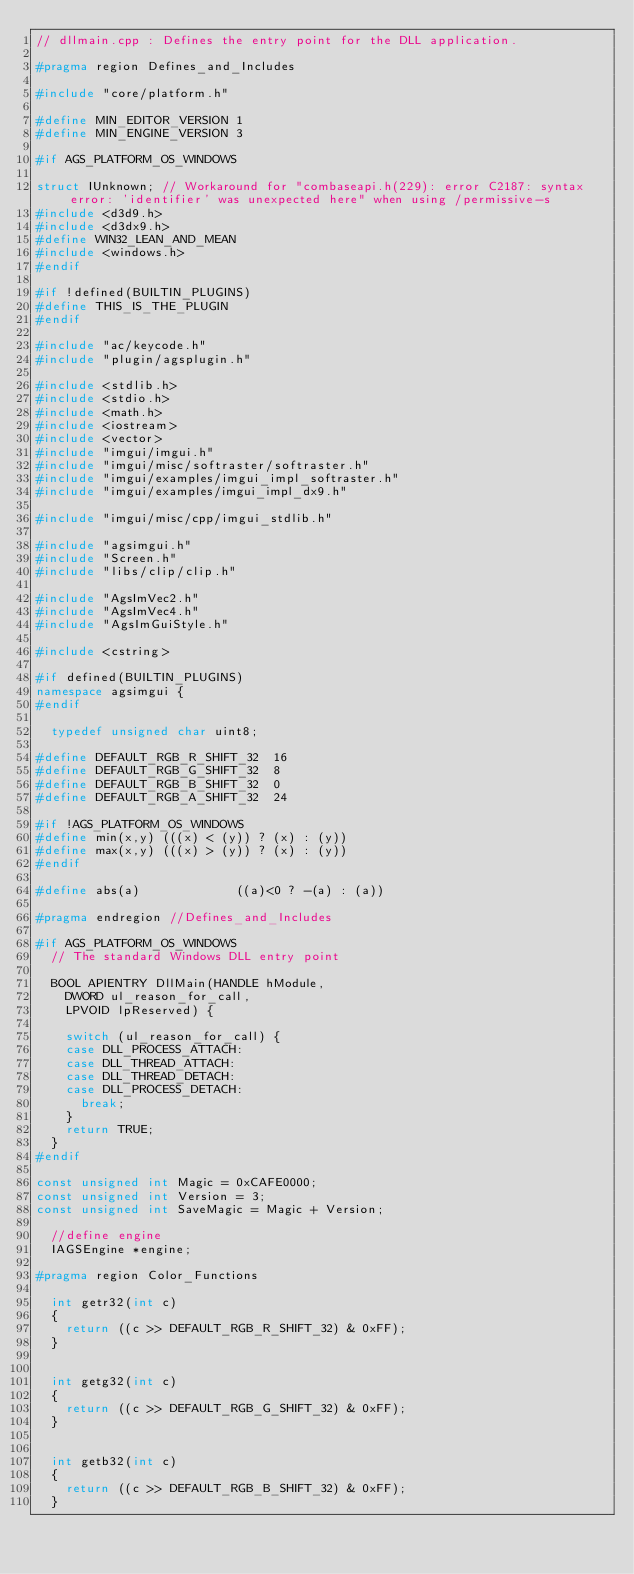Convert code to text. <code><loc_0><loc_0><loc_500><loc_500><_C++_>// dllmain.cpp : Defines the entry point for the DLL application.

#pragma region Defines_and_Includes

#include "core/platform.h"

#define MIN_EDITOR_VERSION 1
#define MIN_ENGINE_VERSION 3

#if AGS_PLATFORM_OS_WINDOWS

struct IUnknown; // Workaround for "combaseapi.h(229): error C2187: syntax error: 'identifier' was unexpected here" when using /permissive-s
#include <d3d9.h>
#include <d3dx9.h>
#define WIN32_LEAN_AND_MEAN
#include <windows.h>
#endif

#if !defined(BUILTIN_PLUGINS)
#define THIS_IS_THE_PLUGIN
#endif

#include "ac/keycode.h"
#include "plugin/agsplugin.h"

#include <stdlib.h>
#include <stdio.h>
#include <math.h>
#include <iostream>
#include <vector>
#include "imgui/imgui.h" 
#include "imgui/misc/softraster/softraster.h"
#include "imgui/examples/imgui_impl_softraster.h"
#include "imgui/examples/imgui_impl_dx9.h"

#include "imgui/misc/cpp/imgui_stdlib.h"

#include "agsimgui.h"
#include "Screen.h"
#include "libs/clip/clip.h"

#include "AgsImVec2.h"
#include "AgsImVec4.h"
#include "AgsImGuiStyle.h"

#include <cstring>

#if defined(BUILTIN_PLUGINS)
namespace agsimgui {
#endif

	typedef unsigned char uint8;

#define DEFAULT_RGB_R_SHIFT_32  16
#define DEFAULT_RGB_G_SHIFT_32  8
#define DEFAULT_RGB_B_SHIFT_32  0
#define DEFAULT_RGB_A_SHIFT_32  24

#if !AGS_PLATFORM_OS_WINDOWS
#define min(x,y) (((x) < (y)) ? (x) : (y))
#define max(x,y) (((x) > (y)) ? (x) : (y))
#endif

#define abs(a)             ((a)<0 ? -(a) : (a))

#pragma endregion //Defines_and_Includes

#if AGS_PLATFORM_OS_WINDOWS
	// The standard Windows DLL entry point

	BOOL APIENTRY DllMain(HANDLE hModule,
		DWORD ul_reason_for_call,
		LPVOID lpReserved) {

		switch (ul_reason_for_call) {
		case DLL_PROCESS_ATTACH:
		case DLL_THREAD_ATTACH:
		case DLL_THREAD_DETACH:
		case DLL_PROCESS_DETACH:
			break;
		}
		return TRUE;
	}
#endif

const unsigned int Magic = 0xCAFE0000;
const unsigned int Version = 3;
const unsigned int SaveMagic = Magic + Version;

	//define engine
	IAGSEngine *engine;

#pragma region Color_Functions

	int getr32(int c)
	{
		return ((c >> DEFAULT_RGB_R_SHIFT_32) & 0xFF);
	}


	int getg32(int c)
	{
		return ((c >> DEFAULT_RGB_G_SHIFT_32) & 0xFF);
	}


	int getb32(int c)
	{
		return ((c >> DEFAULT_RGB_B_SHIFT_32) & 0xFF);
	}

</code> 